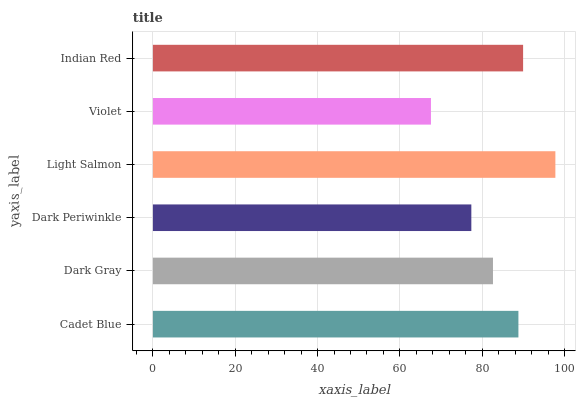Is Violet the minimum?
Answer yes or no. Yes. Is Light Salmon the maximum?
Answer yes or no. Yes. Is Dark Gray the minimum?
Answer yes or no. No. Is Dark Gray the maximum?
Answer yes or no. No. Is Cadet Blue greater than Dark Gray?
Answer yes or no. Yes. Is Dark Gray less than Cadet Blue?
Answer yes or no. Yes. Is Dark Gray greater than Cadet Blue?
Answer yes or no. No. Is Cadet Blue less than Dark Gray?
Answer yes or no. No. Is Cadet Blue the high median?
Answer yes or no. Yes. Is Dark Gray the low median?
Answer yes or no. Yes. Is Light Salmon the high median?
Answer yes or no. No. Is Violet the low median?
Answer yes or no. No. 